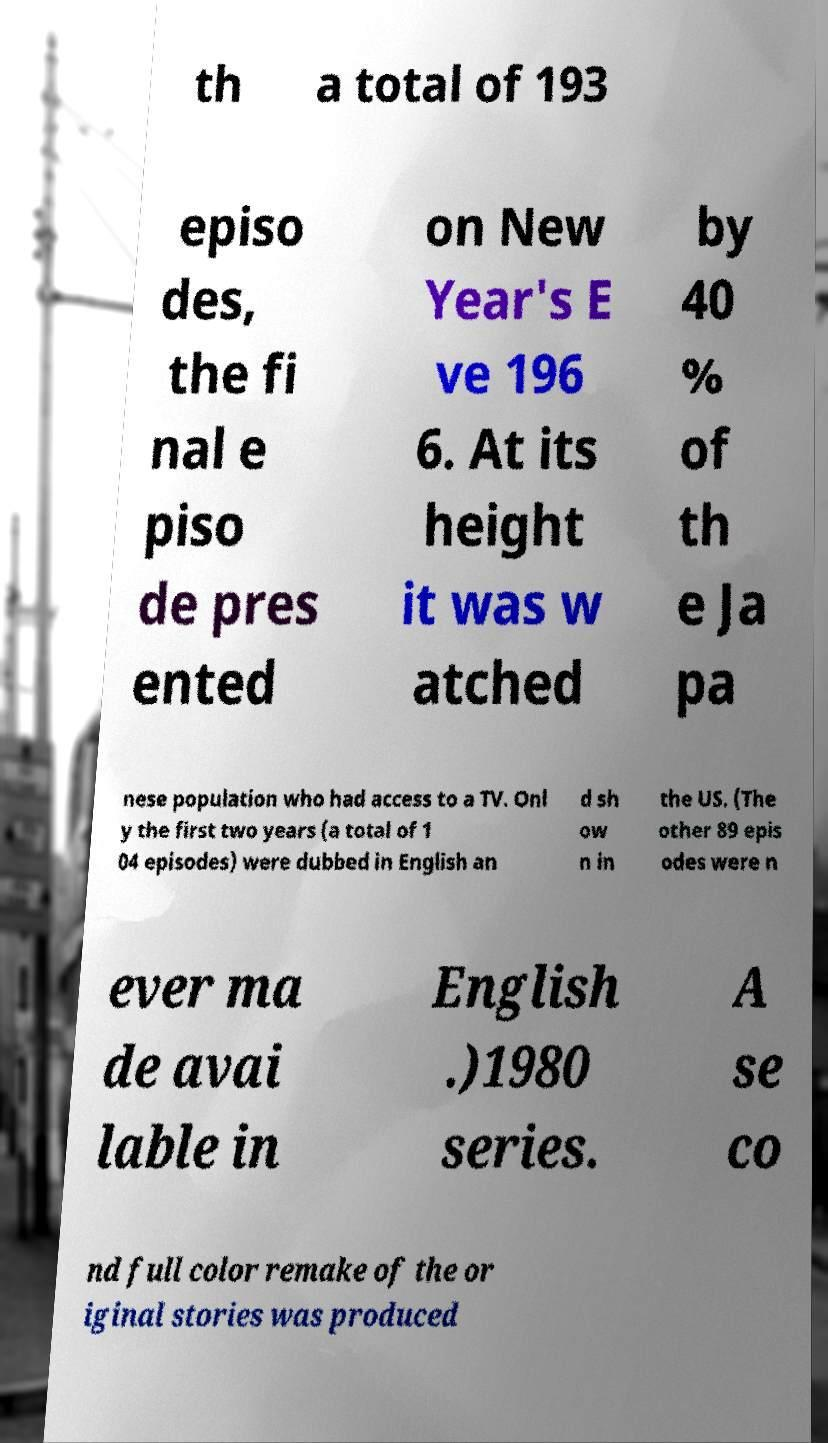What messages or text are displayed in this image? I need them in a readable, typed format. th a total of 193 episo des, the fi nal e piso de pres ented on New Year's E ve 196 6. At its height it was w atched by 40 % of th e Ja pa nese population who had access to a TV. Onl y the first two years (a total of 1 04 episodes) were dubbed in English an d sh ow n in the US. (The other 89 epis odes were n ever ma de avai lable in English .)1980 series. A se co nd full color remake of the or iginal stories was produced 